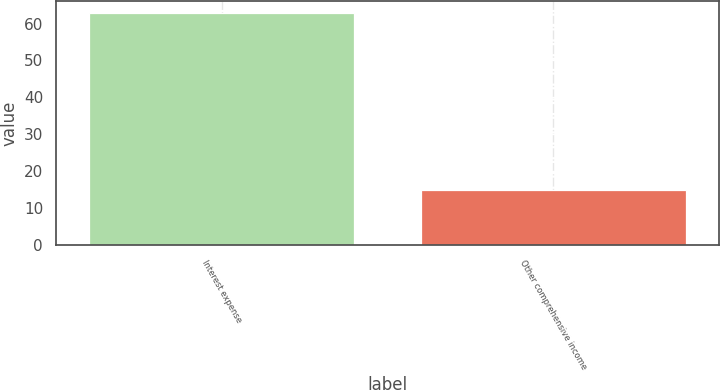Convert chart. <chart><loc_0><loc_0><loc_500><loc_500><bar_chart><fcel>Interest expense<fcel>Other comprehensive income<nl><fcel>63<fcel>15<nl></chart> 